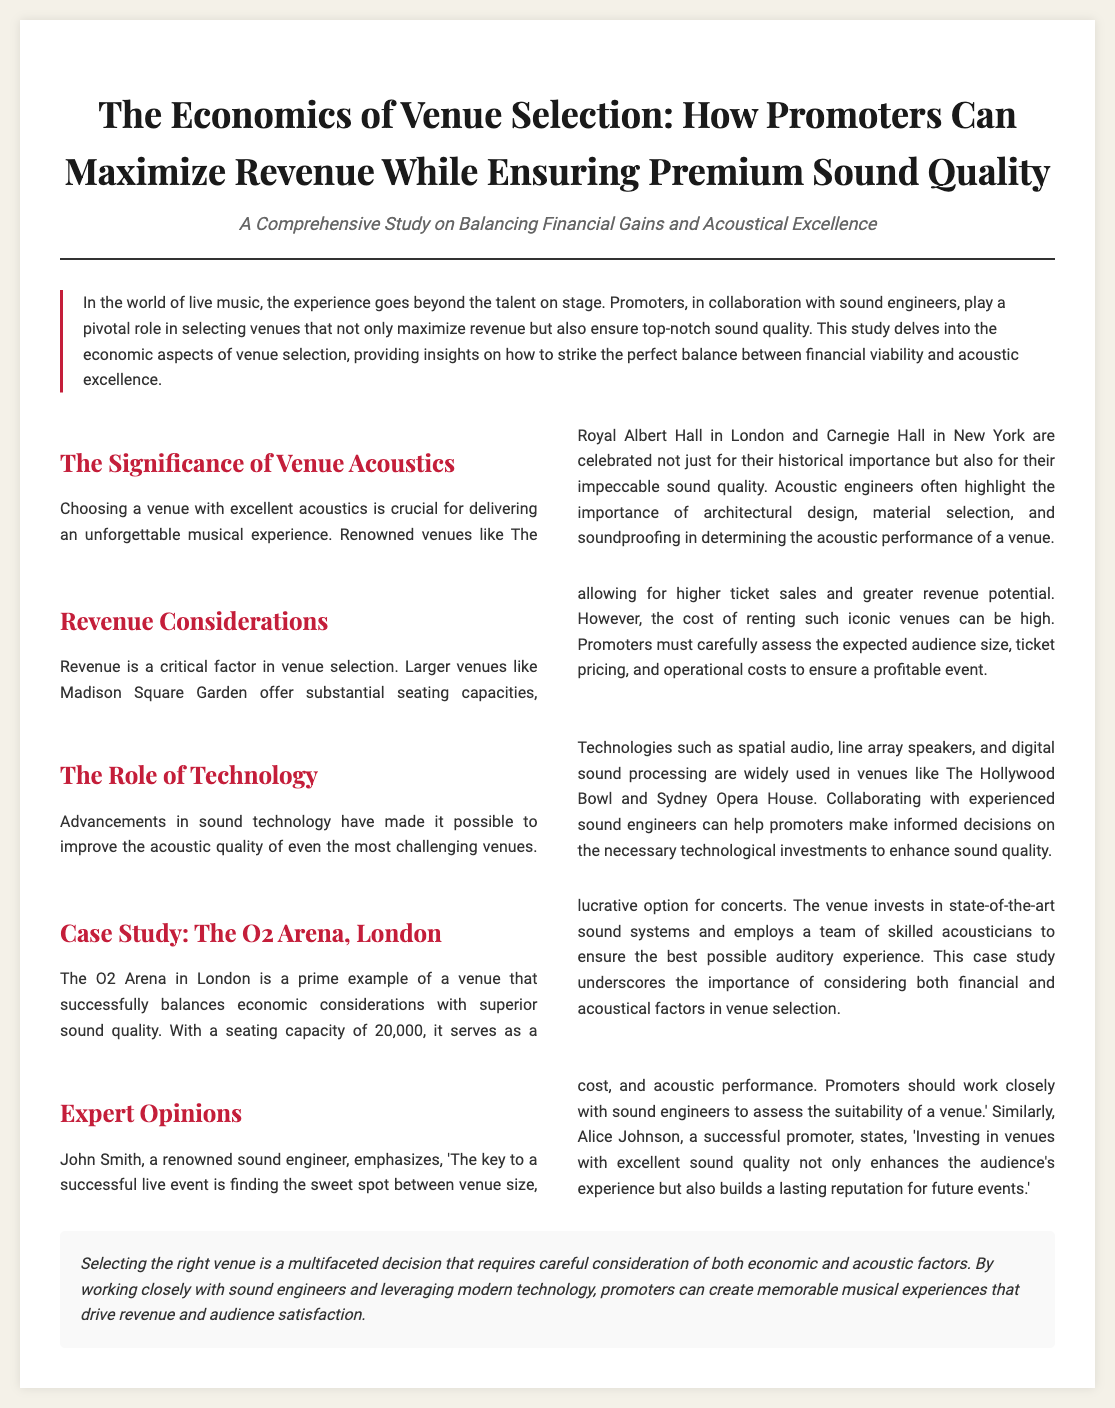What is the title of the document? The title is prominently displayed at the top of the document and reads "The Economics of Venue Selection: How Promoters Can Maximize Revenue While Ensuring Premium Sound Quality".
Answer: The Economics of Venue Selection: How Promoters Can Maximize Revenue While Ensuring Premium Sound Quality How many sections are there in the document? The document contains several sections outlined with headings, namely: The Significance of Venue Acoustics, Revenue Considerations, The Role of Technology, Case Study: The O2 Arena, London, and Expert Opinions.
Answer: Five What venue is highlighted as an example in the case study? The case study section specifies an example venue that showcases effective balance between economic and acoustic factors.
Answer: The O2 Arena, London Who is quoted regarding the importance of venue selection? The section on Expert Opinions includes quotes from two professionals; one of them is a renowned sound engineer.
Answer: John Smith What is emphasized as a critical factor in venue selection? The introduction notes a pivotal aspect of selecting venues that relates to financial viability and musical experience.
Answer: Revenue What technology is mentioned as improving acoustic quality? The document lists advancements in technology that are utilized to enhance sound in challenging venues.
Answer: Spatial audio What is a noted characteristic of The O2 Arena? This venue is characterized by its substantial seating capacity which plays a role in attracting larger audiences.
Answer: 20,000 According to a promoter, what enhances the audience's experience? The Expert Opinions section highlights the value of investing in certain venue attributes for audience satisfaction.
Answer: Excellent sound quality 